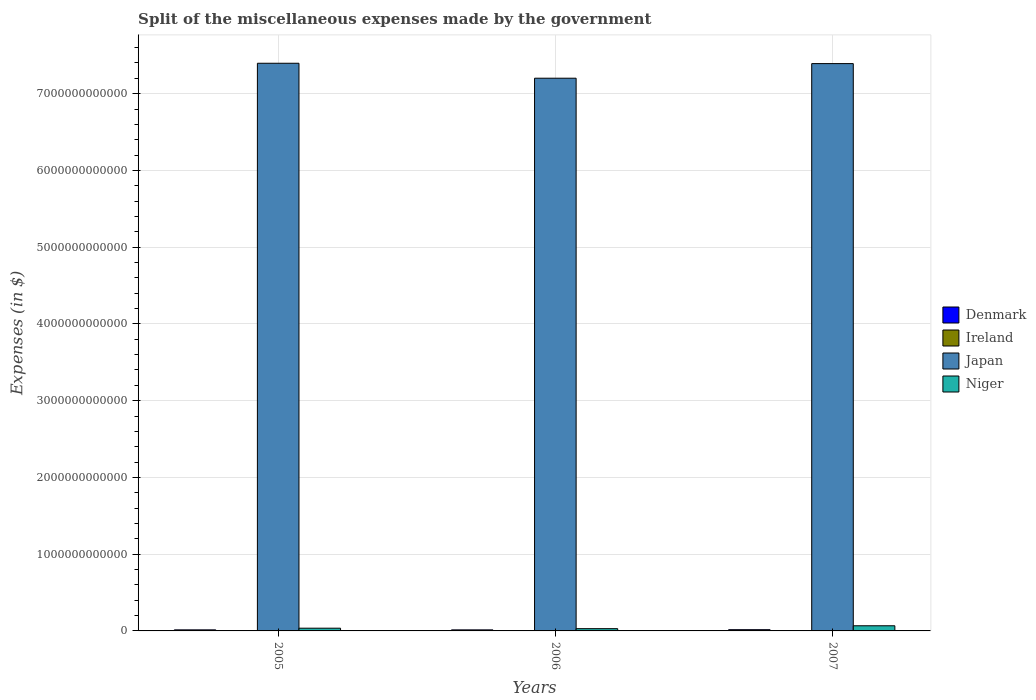Are the number of bars on each tick of the X-axis equal?
Give a very brief answer. Yes. How many bars are there on the 1st tick from the left?
Make the answer very short. 4. How many bars are there on the 1st tick from the right?
Your answer should be compact. 4. In how many cases, is the number of bars for a given year not equal to the number of legend labels?
Keep it short and to the point. 0. What is the miscellaneous expenses made by the government in Niger in 2005?
Provide a short and direct response. 3.56e+1. Across all years, what is the maximum miscellaneous expenses made by the government in Japan?
Keep it short and to the point. 7.40e+12. Across all years, what is the minimum miscellaneous expenses made by the government in Japan?
Offer a very short reply. 7.20e+12. In which year was the miscellaneous expenses made by the government in Ireland maximum?
Make the answer very short. 2007. In which year was the miscellaneous expenses made by the government in Japan minimum?
Give a very brief answer. 2006. What is the total miscellaneous expenses made by the government in Niger in the graph?
Provide a short and direct response. 1.32e+11. What is the difference between the miscellaneous expenses made by the government in Denmark in 2006 and that in 2007?
Offer a very short reply. -2.40e+09. What is the difference between the miscellaneous expenses made by the government in Niger in 2007 and the miscellaneous expenses made by the government in Japan in 2005?
Provide a succinct answer. -7.33e+12. What is the average miscellaneous expenses made by the government in Niger per year?
Provide a succinct answer. 4.40e+1. In the year 2006, what is the difference between the miscellaneous expenses made by the government in Ireland and miscellaneous expenses made by the government in Niger?
Make the answer very short. -2.86e+1. In how many years, is the miscellaneous expenses made by the government in Ireland greater than 4000000000000 $?
Offer a terse response. 0. What is the ratio of the miscellaneous expenses made by the government in Japan in 2005 to that in 2006?
Your response must be concise. 1.03. Is the miscellaneous expenses made by the government in Japan in 2005 less than that in 2006?
Give a very brief answer. No. Is the difference between the miscellaneous expenses made by the government in Ireland in 2005 and 2007 greater than the difference between the miscellaneous expenses made by the government in Niger in 2005 and 2007?
Your answer should be very brief. Yes. What is the difference between the highest and the second highest miscellaneous expenses made by the government in Niger?
Your response must be concise. 3.14e+1. What is the difference between the highest and the lowest miscellaneous expenses made by the government in Ireland?
Make the answer very short. 1.78e+08. Is it the case that in every year, the sum of the miscellaneous expenses made by the government in Ireland and miscellaneous expenses made by the government in Niger is greater than the sum of miscellaneous expenses made by the government in Denmark and miscellaneous expenses made by the government in Japan?
Offer a very short reply. No. What does the 4th bar from the left in 2005 represents?
Make the answer very short. Niger. What does the 2nd bar from the right in 2006 represents?
Make the answer very short. Japan. Is it the case that in every year, the sum of the miscellaneous expenses made by the government in Niger and miscellaneous expenses made by the government in Japan is greater than the miscellaneous expenses made by the government in Denmark?
Ensure brevity in your answer.  Yes. How many bars are there?
Make the answer very short. 12. Are all the bars in the graph horizontal?
Provide a succinct answer. No. What is the difference between two consecutive major ticks on the Y-axis?
Give a very brief answer. 1.00e+12. Does the graph contain grids?
Offer a very short reply. Yes. What is the title of the graph?
Provide a short and direct response. Split of the miscellaneous expenses made by the government. What is the label or title of the Y-axis?
Give a very brief answer. Expenses (in $). What is the Expenses (in $) in Denmark in 2005?
Give a very brief answer. 1.38e+1. What is the Expenses (in $) in Ireland in 2005?
Ensure brevity in your answer.  7.97e+08. What is the Expenses (in $) in Japan in 2005?
Provide a succinct answer. 7.40e+12. What is the Expenses (in $) of Niger in 2005?
Make the answer very short. 3.56e+1. What is the Expenses (in $) in Denmark in 2006?
Offer a terse response. 1.36e+1. What is the Expenses (in $) in Ireland in 2006?
Make the answer very short. 9.16e+08. What is the Expenses (in $) in Japan in 2006?
Keep it short and to the point. 7.20e+12. What is the Expenses (in $) in Niger in 2006?
Give a very brief answer. 2.95e+1. What is the Expenses (in $) of Denmark in 2007?
Offer a very short reply. 1.60e+1. What is the Expenses (in $) of Ireland in 2007?
Your answer should be very brief. 9.75e+08. What is the Expenses (in $) in Japan in 2007?
Ensure brevity in your answer.  7.39e+12. What is the Expenses (in $) in Niger in 2007?
Provide a short and direct response. 6.70e+1. Across all years, what is the maximum Expenses (in $) of Denmark?
Make the answer very short. 1.60e+1. Across all years, what is the maximum Expenses (in $) of Ireland?
Your answer should be very brief. 9.75e+08. Across all years, what is the maximum Expenses (in $) in Japan?
Ensure brevity in your answer.  7.40e+12. Across all years, what is the maximum Expenses (in $) in Niger?
Provide a succinct answer. 6.70e+1. Across all years, what is the minimum Expenses (in $) of Denmark?
Give a very brief answer. 1.36e+1. Across all years, what is the minimum Expenses (in $) of Ireland?
Offer a terse response. 7.97e+08. Across all years, what is the minimum Expenses (in $) in Japan?
Your answer should be compact. 7.20e+12. Across all years, what is the minimum Expenses (in $) in Niger?
Ensure brevity in your answer.  2.95e+1. What is the total Expenses (in $) in Denmark in the graph?
Ensure brevity in your answer.  4.34e+1. What is the total Expenses (in $) in Ireland in the graph?
Make the answer very short. 2.69e+09. What is the total Expenses (in $) of Japan in the graph?
Make the answer very short. 2.20e+13. What is the total Expenses (in $) of Niger in the graph?
Your response must be concise. 1.32e+11. What is the difference between the Expenses (in $) in Denmark in 2005 and that in 2006?
Offer a terse response. 2.23e+08. What is the difference between the Expenses (in $) of Ireland in 2005 and that in 2006?
Your response must be concise. -1.19e+08. What is the difference between the Expenses (in $) of Japan in 2005 and that in 2006?
Provide a succinct answer. 1.95e+11. What is the difference between the Expenses (in $) in Niger in 2005 and that in 2006?
Give a very brief answer. 6.05e+09. What is the difference between the Expenses (in $) of Denmark in 2005 and that in 2007?
Provide a short and direct response. -2.17e+09. What is the difference between the Expenses (in $) in Ireland in 2005 and that in 2007?
Offer a very short reply. -1.78e+08. What is the difference between the Expenses (in $) of Japan in 2005 and that in 2007?
Make the answer very short. 4.50e+09. What is the difference between the Expenses (in $) of Niger in 2005 and that in 2007?
Offer a very short reply. -3.14e+1. What is the difference between the Expenses (in $) in Denmark in 2006 and that in 2007?
Provide a succinct answer. -2.40e+09. What is the difference between the Expenses (in $) of Ireland in 2006 and that in 2007?
Offer a terse response. -5.92e+07. What is the difference between the Expenses (in $) of Japan in 2006 and that in 2007?
Keep it short and to the point. -1.90e+11. What is the difference between the Expenses (in $) of Niger in 2006 and that in 2007?
Offer a terse response. -3.75e+1. What is the difference between the Expenses (in $) of Denmark in 2005 and the Expenses (in $) of Ireland in 2006?
Keep it short and to the point. 1.29e+1. What is the difference between the Expenses (in $) in Denmark in 2005 and the Expenses (in $) in Japan in 2006?
Give a very brief answer. -7.19e+12. What is the difference between the Expenses (in $) in Denmark in 2005 and the Expenses (in $) in Niger in 2006?
Make the answer very short. -1.57e+1. What is the difference between the Expenses (in $) of Ireland in 2005 and the Expenses (in $) of Japan in 2006?
Offer a very short reply. -7.20e+12. What is the difference between the Expenses (in $) of Ireland in 2005 and the Expenses (in $) of Niger in 2006?
Make the answer very short. -2.87e+1. What is the difference between the Expenses (in $) in Japan in 2005 and the Expenses (in $) in Niger in 2006?
Make the answer very short. 7.37e+12. What is the difference between the Expenses (in $) of Denmark in 2005 and the Expenses (in $) of Ireland in 2007?
Offer a very short reply. 1.28e+1. What is the difference between the Expenses (in $) of Denmark in 2005 and the Expenses (in $) of Japan in 2007?
Your response must be concise. -7.38e+12. What is the difference between the Expenses (in $) in Denmark in 2005 and the Expenses (in $) in Niger in 2007?
Provide a succinct answer. -5.32e+1. What is the difference between the Expenses (in $) of Ireland in 2005 and the Expenses (in $) of Japan in 2007?
Your response must be concise. -7.39e+12. What is the difference between the Expenses (in $) of Ireland in 2005 and the Expenses (in $) of Niger in 2007?
Offer a terse response. -6.62e+1. What is the difference between the Expenses (in $) in Japan in 2005 and the Expenses (in $) in Niger in 2007?
Your answer should be compact. 7.33e+12. What is the difference between the Expenses (in $) in Denmark in 2006 and the Expenses (in $) in Ireland in 2007?
Offer a very short reply. 1.26e+1. What is the difference between the Expenses (in $) of Denmark in 2006 and the Expenses (in $) of Japan in 2007?
Make the answer very short. -7.38e+12. What is the difference between the Expenses (in $) of Denmark in 2006 and the Expenses (in $) of Niger in 2007?
Your response must be concise. -5.34e+1. What is the difference between the Expenses (in $) in Ireland in 2006 and the Expenses (in $) in Japan in 2007?
Your answer should be compact. -7.39e+12. What is the difference between the Expenses (in $) in Ireland in 2006 and the Expenses (in $) in Niger in 2007?
Your response must be concise. -6.61e+1. What is the difference between the Expenses (in $) in Japan in 2006 and the Expenses (in $) in Niger in 2007?
Give a very brief answer. 7.13e+12. What is the average Expenses (in $) in Denmark per year?
Give a very brief answer. 1.45e+1. What is the average Expenses (in $) in Ireland per year?
Your answer should be compact. 8.96e+08. What is the average Expenses (in $) of Japan per year?
Provide a short and direct response. 7.33e+12. What is the average Expenses (in $) in Niger per year?
Keep it short and to the point. 4.40e+1. In the year 2005, what is the difference between the Expenses (in $) in Denmark and Expenses (in $) in Ireland?
Ensure brevity in your answer.  1.30e+1. In the year 2005, what is the difference between the Expenses (in $) of Denmark and Expenses (in $) of Japan?
Your answer should be very brief. -7.38e+12. In the year 2005, what is the difference between the Expenses (in $) of Denmark and Expenses (in $) of Niger?
Keep it short and to the point. -2.17e+1. In the year 2005, what is the difference between the Expenses (in $) of Ireland and Expenses (in $) of Japan?
Offer a very short reply. -7.40e+12. In the year 2005, what is the difference between the Expenses (in $) of Ireland and Expenses (in $) of Niger?
Offer a terse response. -3.48e+1. In the year 2005, what is the difference between the Expenses (in $) in Japan and Expenses (in $) in Niger?
Your response must be concise. 7.36e+12. In the year 2006, what is the difference between the Expenses (in $) in Denmark and Expenses (in $) in Ireland?
Your answer should be very brief. 1.27e+1. In the year 2006, what is the difference between the Expenses (in $) in Denmark and Expenses (in $) in Japan?
Your answer should be very brief. -7.19e+12. In the year 2006, what is the difference between the Expenses (in $) in Denmark and Expenses (in $) in Niger?
Your response must be concise. -1.59e+1. In the year 2006, what is the difference between the Expenses (in $) of Ireland and Expenses (in $) of Japan?
Offer a very short reply. -7.20e+12. In the year 2006, what is the difference between the Expenses (in $) in Ireland and Expenses (in $) in Niger?
Your answer should be very brief. -2.86e+1. In the year 2006, what is the difference between the Expenses (in $) in Japan and Expenses (in $) in Niger?
Provide a succinct answer. 7.17e+12. In the year 2007, what is the difference between the Expenses (in $) of Denmark and Expenses (in $) of Ireland?
Provide a succinct answer. 1.50e+1. In the year 2007, what is the difference between the Expenses (in $) of Denmark and Expenses (in $) of Japan?
Your response must be concise. -7.38e+12. In the year 2007, what is the difference between the Expenses (in $) of Denmark and Expenses (in $) of Niger?
Your answer should be very brief. -5.10e+1. In the year 2007, what is the difference between the Expenses (in $) of Ireland and Expenses (in $) of Japan?
Provide a short and direct response. -7.39e+12. In the year 2007, what is the difference between the Expenses (in $) in Ireland and Expenses (in $) in Niger?
Give a very brief answer. -6.60e+1. In the year 2007, what is the difference between the Expenses (in $) of Japan and Expenses (in $) of Niger?
Provide a succinct answer. 7.33e+12. What is the ratio of the Expenses (in $) in Denmark in 2005 to that in 2006?
Provide a short and direct response. 1.02. What is the ratio of the Expenses (in $) of Ireland in 2005 to that in 2006?
Make the answer very short. 0.87. What is the ratio of the Expenses (in $) of Niger in 2005 to that in 2006?
Your answer should be very brief. 1.2. What is the ratio of the Expenses (in $) of Denmark in 2005 to that in 2007?
Your answer should be very brief. 0.86. What is the ratio of the Expenses (in $) of Ireland in 2005 to that in 2007?
Provide a succinct answer. 0.82. What is the ratio of the Expenses (in $) in Japan in 2005 to that in 2007?
Offer a terse response. 1. What is the ratio of the Expenses (in $) of Niger in 2005 to that in 2007?
Offer a terse response. 0.53. What is the ratio of the Expenses (in $) of Denmark in 2006 to that in 2007?
Ensure brevity in your answer.  0.85. What is the ratio of the Expenses (in $) of Ireland in 2006 to that in 2007?
Ensure brevity in your answer.  0.94. What is the ratio of the Expenses (in $) in Japan in 2006 to that in 2007?
Your answer should be compact. 0.97. What is the ratio of the Expenses (in $) of Niger in 2006 to that in 2007?
Your answer should be compact. 0.44. What is the difference between the highest and the second highest Expenses (in $) of Denmark?
Your answer should be compact. 2.17e+09. What is the difference between the highest and the second highest Expenses (in $) of Ireland?
Keep it short and to the point. 5.92e+07. What is the difference between the highest and the second highest Expenses (in $) in Japan?
Your answer should be very brief. 4.50e+09. What is the difference between the highest and the second highest Expenses (in $) of Niger?
Your answer should be compact. 3.14e+1. What is the difference between the highest and the lowest Expenses (in $) of Denmark?
Keep it short and to the point. 2.40e+09. What is the difference between the highest and the lowest Expenses (in $) in Ireland?
Make the answer very short. 1.78e+08. What is the difference between the highest and the lowest Expenses (in $) of Japan?
Offer a very short reply. 1.95e+11. What is the difference between the highest and the lowest Expenses (in $) in Niger?
Offer a terse response. 3.75e+1. 